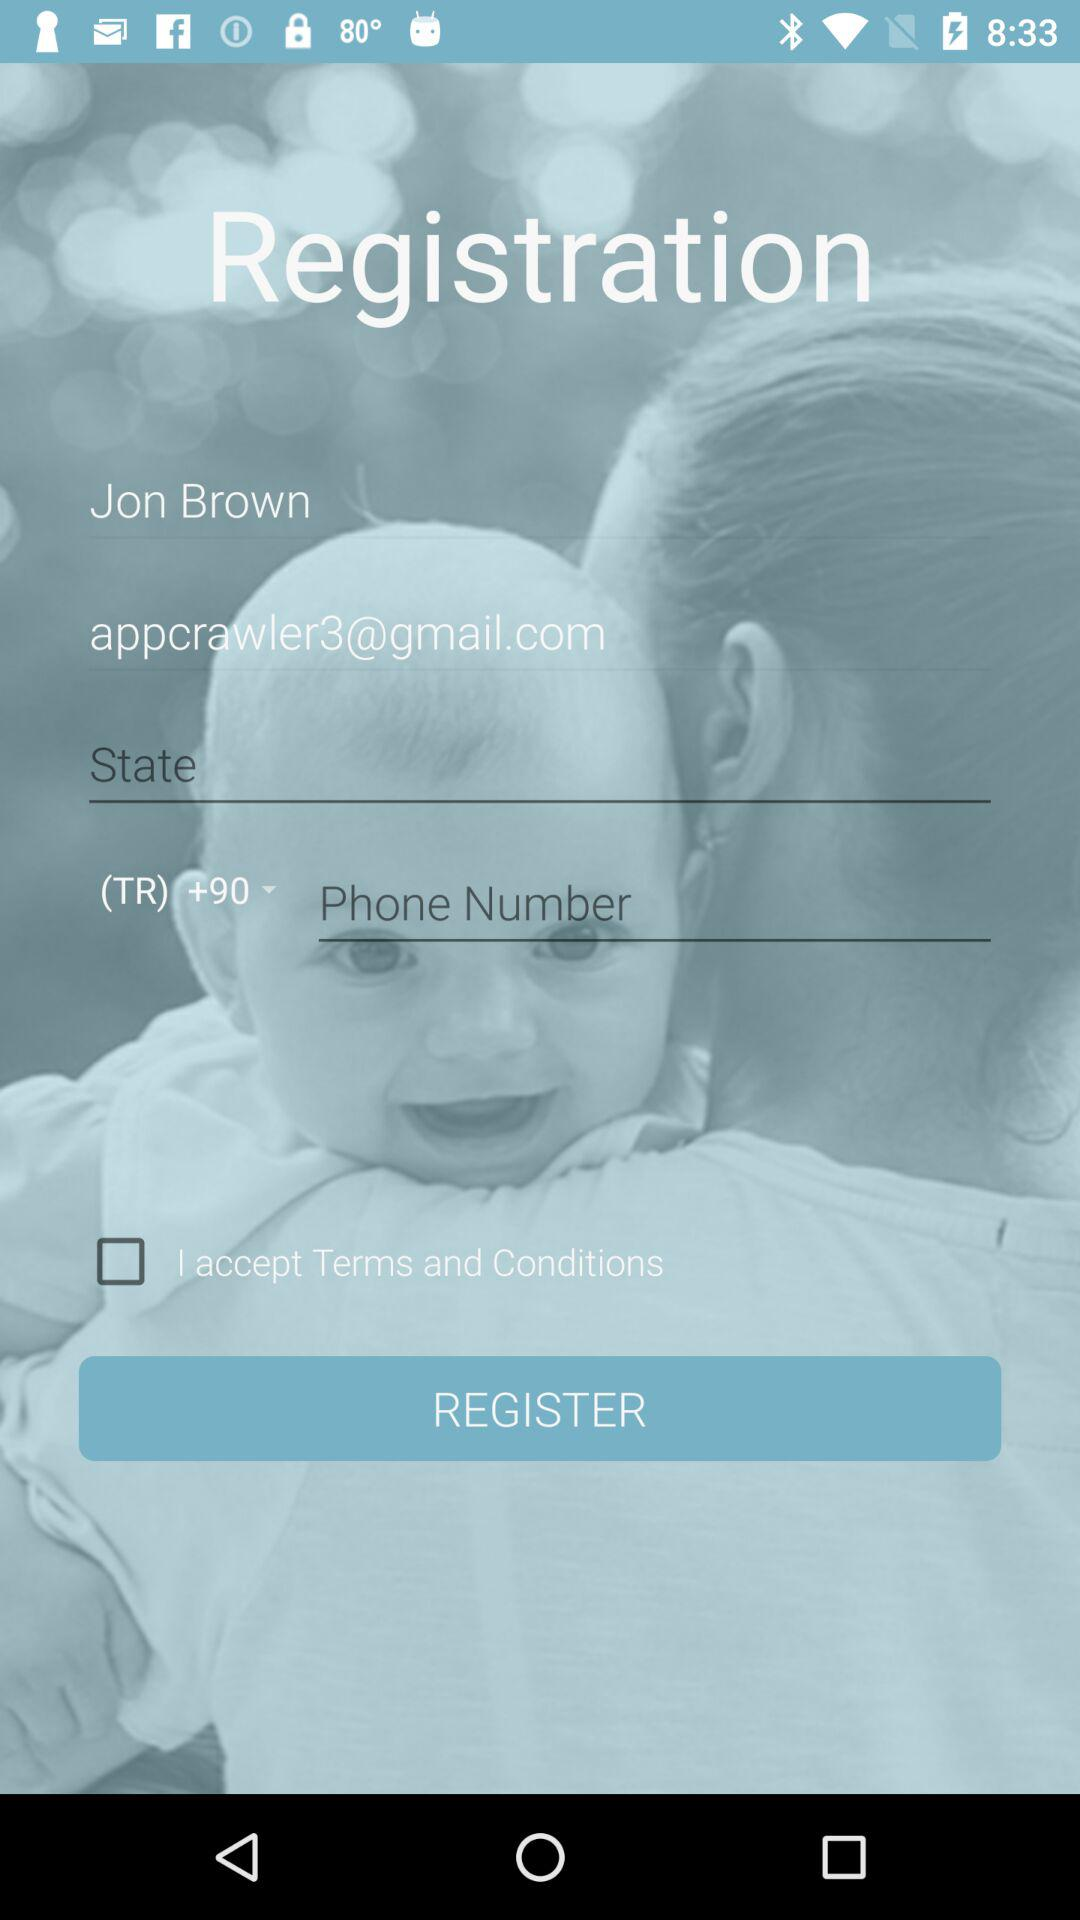What's the Gmail address? The Gmail address is appcrawler3@gmail.com. 